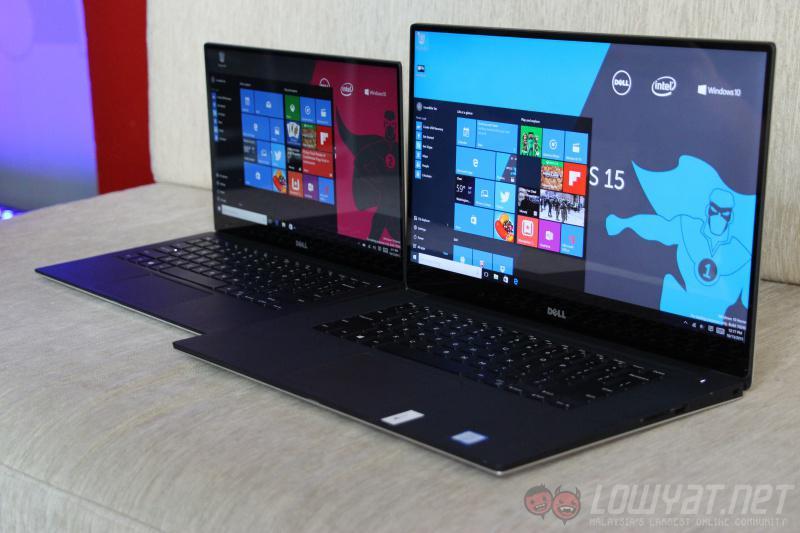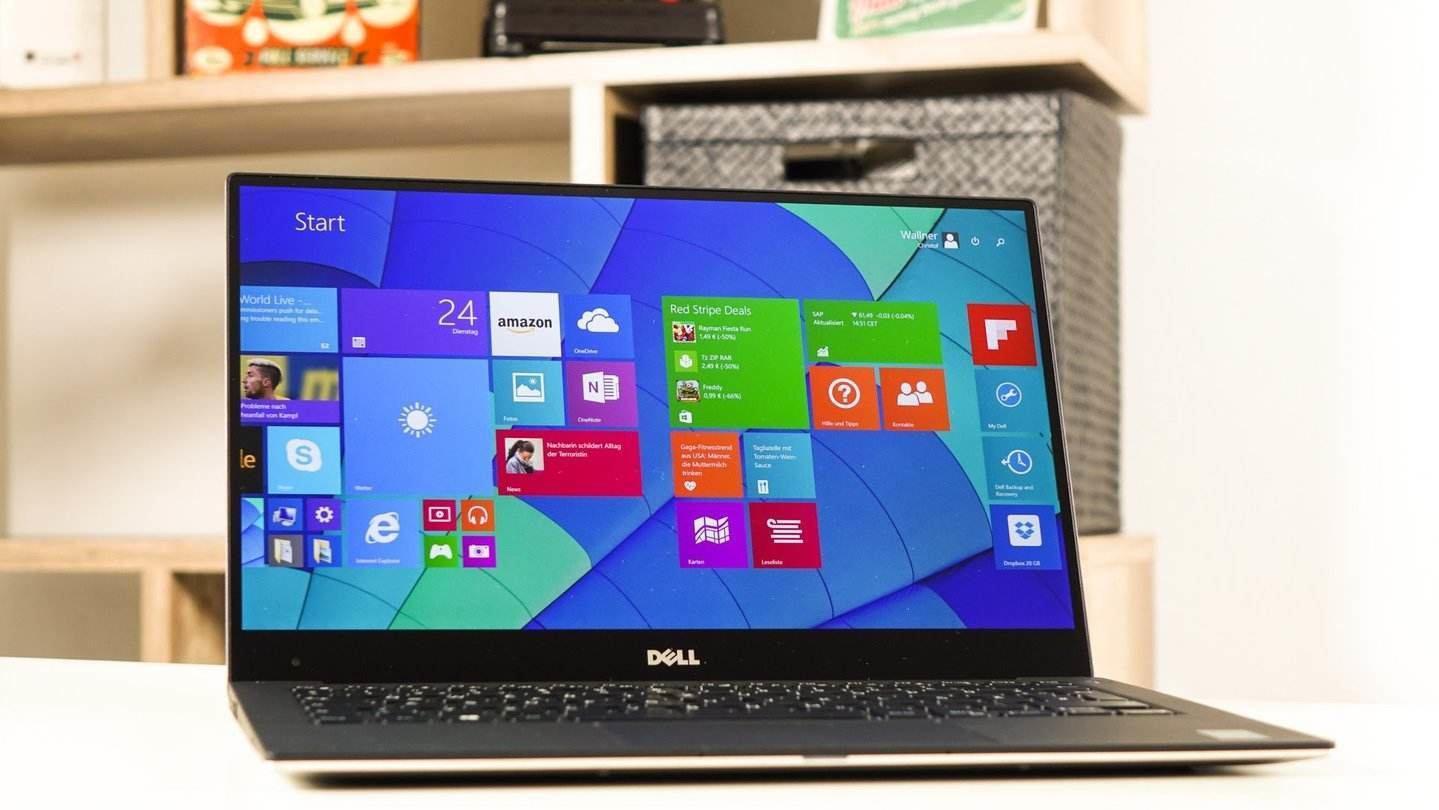The first image is the image on the left, the second image is the image on the right. Evaluate the accuracy of this statement regarding the images: "There are more computers in the image on the left.". Is it true? Answer yes or no. Yes. The first image is the image on the left, the second image is the image on the right. Evaluate the accuracy of this statement regarding the images: "One of the pictures has more than one laptop.". Is it true? Answer yes or no. Yes. 